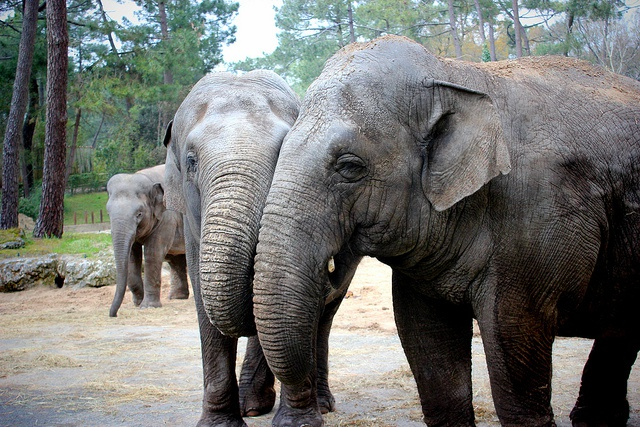Describe the objects in this image and their specific colors. I can see elephant in black, gray, darkgray, and lightgray tones, elephant in black, lightgray, darkgray, and gray tones, and elephant in black, gray, darkgray, and lightgray tones in this image. 